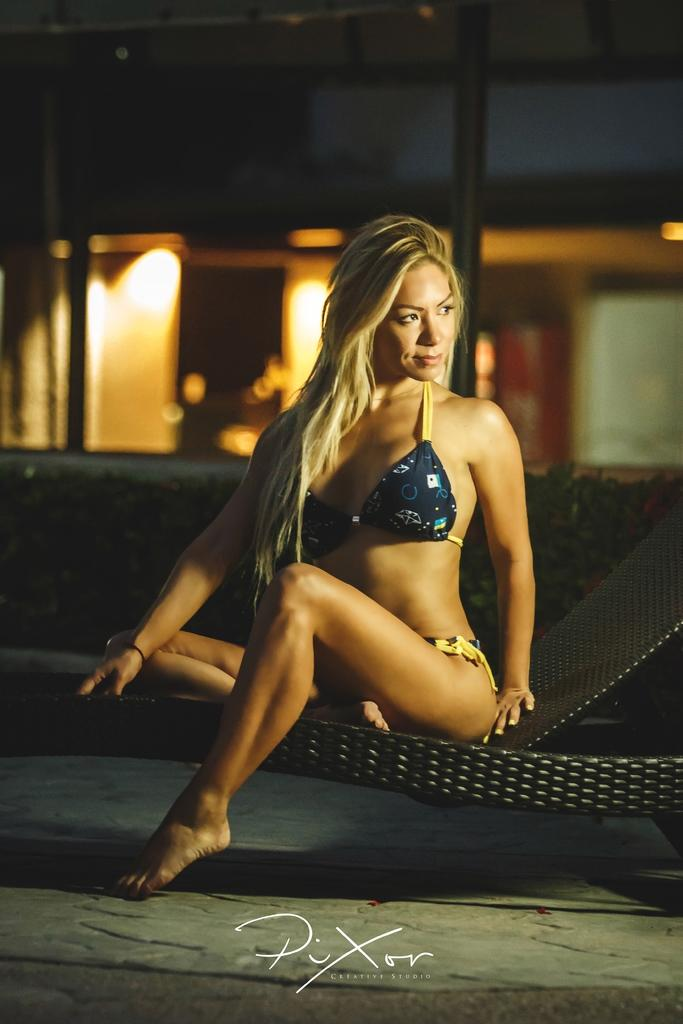Who is present in the image? There is a woman in the image. What is the woman doing in the image? The woman is sitting. What is the woman wearing in the image? The woman is wearing a bikini. What type of kettle can be seen in the image? There is no kettle present in the image. What kind of sack is the woman carrying in the image? There is no sack present in the image; the woman is wearing a bikini. 